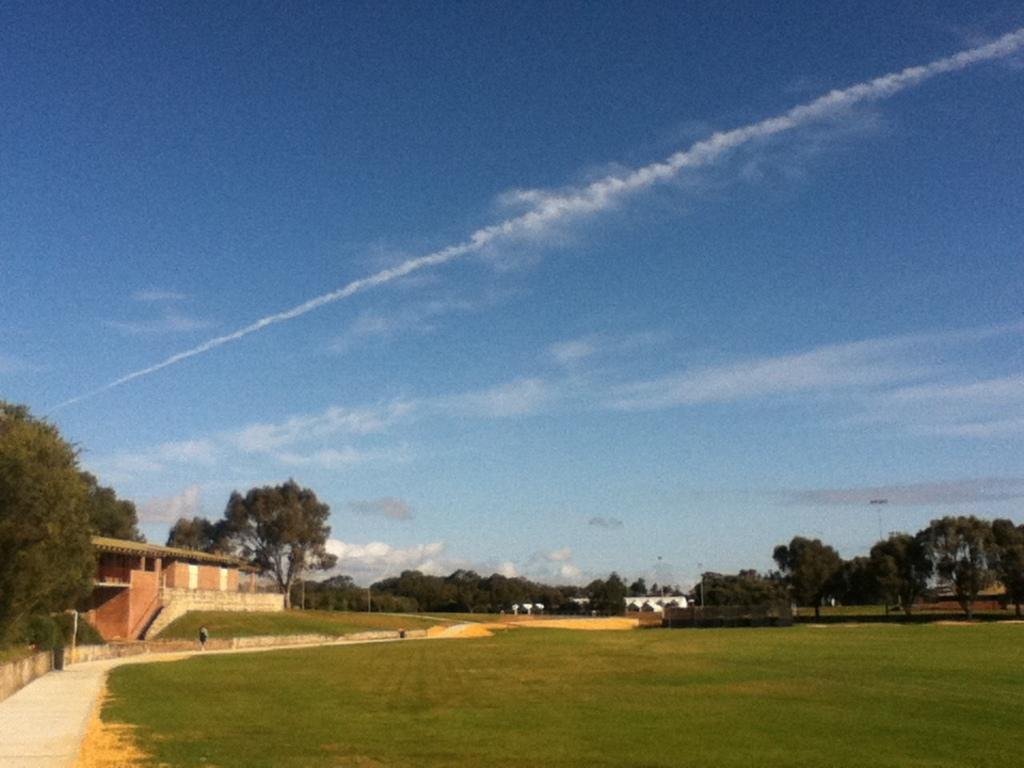Can you describe this image briefly? In this picture we can see a man, beside to him we can find few trees and a house, in the background we can find a pole and clouds. 